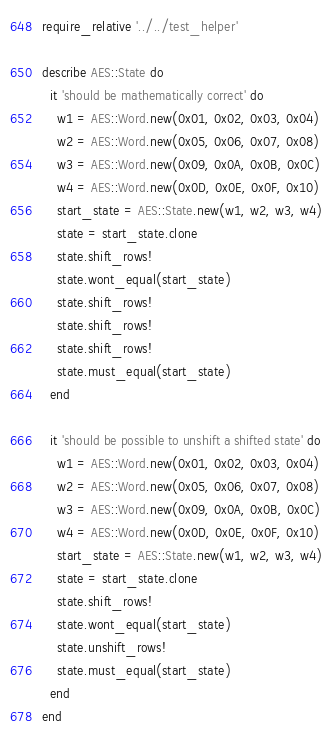<code> <loc_0><loc_0><loc_500><loc_500><_Ruby_>require_relative '../../test_helper'

describe AES::State do
  it 'should be mathematically correct' do
    w1 = AES::Word.new(0x01, 0x02, 0x03, 0x04)
    w2 = AES::Word.new(0x05, 0x06, 0x07, 0x08)
    w3 = AES::Word.new(0x09, 0x0A, 0x0B, 0x0C)
    w4 = AES::Word.new(0x0D, 0x0E, 0x0F, 0x10)
    start_state = AES::State.new(w1, w2, w3, w4)
    state = start_state.clone
    state.shift_rows!
    state.wont_equal(start_state)
    state.shift_rows!
    state.shift_rows!
    state.shift_rows!
    state.must_equal(start_state)
  end

  it 'should be possible to unshift a shifted state' do
    w1 = AES::Word.new(0x01, 0x02, 0x03, 0x04)
    w2 = AES::Word.new(0x05, 0x06, 0x07, 0x08)
    w3 = AES::Word.new(0x09, 0x0A, 0x0B, 0x0C)
    w4 = AES::Word.new(0x0D, 0x0E, 0x0F, 0x10)
    start_state = AES::State.new(w1, w2, w3, w4)
    state = start_state.clone
    state.shift_rows!
    state.wont_equal(start_state)
    state.unshift_rows!
    state.must_equal(start_state)
  end
end
</code> 